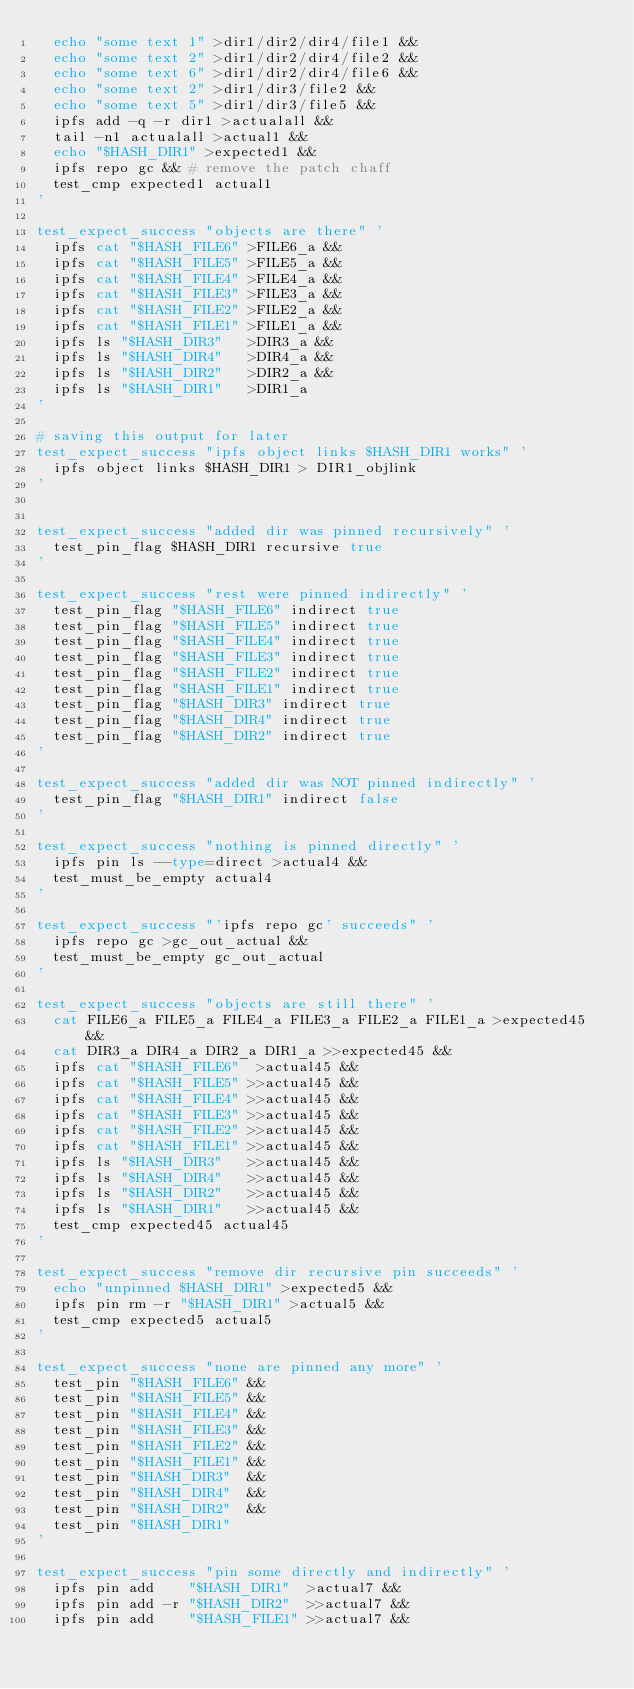Convert code to text. <code><loc_0><loc_0><loc_500><loc_500><_Bash_>	echo "some text 1" >dir1/dir2/dir4/file1 &&
	echo "some text 2" >dir1/dir2/dir4/file2 &&
	echo "some text 6" >dir1/dir2/dir4/file6 &&
	echo "some text 2" >dir1/dir3/file2 &&
	echo "some text 5" >dir1/dir3/file5 &&
	ipfs add -q -r dir1 >actualall &&
	tail -n1 actualall >actual1 &&
	echo "$HASH_DIR1" >expected1 &&
	ipfs repo gc && # remove the patch chaff
	test_cmp expected1 actual1
'

test_expect_success "objects are there" '
	ipfs cat "$HASH_FILE6" >FILE6_a &&
	ipfs cat "$HASH_FILE5" >FILE5_a &&
	ipfs cat "$HASH_FILE4" >FILE4_a &&
	ipfs cat "$HASH_FILE3" >FILE3_a &&
	ipfs cat "$HASH_FILE2" >FILE2_a &&
	ipfs cat "$HASH_FILE1" >FILE1_a &&
	ipfs ls "$HASH_DIR3"   >DIR3_a &&
	ipfs ls "$HASH_DIR4"   >DIR4_a &&
	ipfs ls "$HASH_DIR2"   >DIR2_a &&
	ipfs ls "$HASH_DIR1"   >DIR1_a
'

# saving this output for later
test_expect_success "ipfs object links $HASH_DIR1 works" '
	ipfs object links $HASH_DIR1 > DIR1_objlink
'


test_expect_success "added dir was pinned recursively" '
	test_pin_flag $HASH_DIR1 recursive true
'

test_expect_success "rest were pinned indirectly" '
	test_pin_flag "$HASH_FILE6" indirect true
	test_pin_flag "$HASH_FILE5" indirect true
	test_pin_flag "$HASH_FILE4" indirect true
	test_pin_flag "$HASH_FILE3" indirect true
	test_pin_flag "$HASH_FILE2" indirect true
	test_pin_flag "$HASH_FILE1" indirect true
	test_pin_flag "$HASH_DIR3" indirect true
	test_pin_flag "$HASH_DIR4" indirect true
	test_pin_flag "$HASH_DIR2" indirect true
'

test_expect_success "added dir was NOT pinned indirectly" '
	test_pin_flag "$HASH_DIR1" indirect false
'

test_expect_success "nothing is pinned directly" '
	ipfs pin ls --type=direct >actual4 &&
	test_must_be_empty actual4
'

test_expect_success "'ipfs repo gc' succeeds" '
	ipfs repo gc >gc_out_actual &&
	test_must_be_empty gc_out_actual
'

test_expect_success "objects are still there" '
	cat FILE6_a FILE5_a FILE4_a FILE3_a FILE2_a FILE1_a >expected45 &&
	cat DIR3_a DIR4_a DIR2_a DIR1_a >>expected45 &&
	ipfs cat "$HASH_FILE6"  >actual45 &&
	ipfs cat "$HASH_FILE5" >>actual45 &&
	ipfs cat "$HASH_FILE4" >>actual45 &&
	ipfs cat "$HASH_FILE3" >>actual45 &&
	ipfs cat "$HASH_FILE2" >>actual45 &&
	ipfs cat "$HASH_FILE1" >>actual45 &&
	ipfs ls "$HASH_DIR3"   >>actual45 &&
	ipfs ls "$HASH_DIR4"   >>actual45 &&
	ipfs ls "$HASH_DIR2"   >>actual45 &&
	ipfs ls "$HASH_DIR1"   >>actual45 &&
	test_cmp expected45 actual45
'

test_expect_success "remove dir recursive pin succeeds" '
	echo "unpinned $HASH_DIR1" >expected5 &&
	ipfs pin rm -r "$HASH_DIR1" >actual5 &&
	test_cmp expected5 actual5
'

test_expect_success "none are pinned any more" '
	test_pin "$HASH_FILE6" &&
	test_pin "$HASH_FILE5" &&
	test_pin "$HASH_FILE4" &&
	test_pin "$HASH_FILE3" &&
	test_pin "$HASH_FILE2" &&
	test_pin "$HASH_FILE1" &&
	test_pin "$HASH_DIR3"  &&
	test_pin "$HASH_DIR4"  &&
	test_pin "$HASH_DIR2"  &&
	test_pin "$HASH_DIR1"
'

test_expect_success "pin some directly and indirectly" '
	ipfs pin add    "$HASH_DIR1"  >actual7 &&
	ipfs pin add -r "$HASH_DIR2"  >>actual7 &&
	ipfs pin add    "$HASH_FILE1" >>actual7 &&</code> 